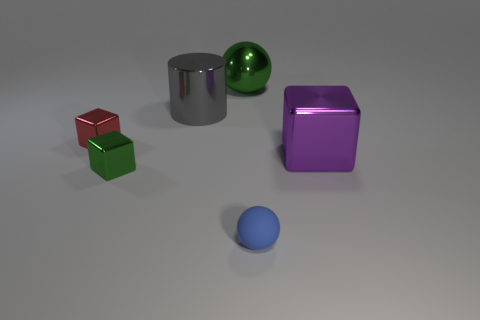Is there any other thing that has the same material as the small sphere?
Give a very brief answer. No. Is the blue rubber thing the same shape as the big green metal object?
Your response must be concise. Yes. How many metal things are either small red blocks or small green cubes?
Provide a short and direct response. 2. Is there a blue ball that has the same size as the red shiny block?
Provide a succinct answer. Yes. The small metal thing that is the same color as the metallic ball is what shape?
Provide a short and direct response. Cube. What number of gray metal balls are the same size as the green shiny sphere?
Provide a short and direct response. 0. Does the ball that is behind the red thing have the same size as the block that is behind the large purple metal thing?
Your response must be concise. No. How many things are green spheres or large things that are in front of the metallic cylinder?
Your response must be concise. 2. The cylinder is what color?
Ensure brevity in your answer.  Gray. What material is the small cube that is behind the big block on the right side of the green thing behind the tiny red cube?
Offer a terse response. Metal. 